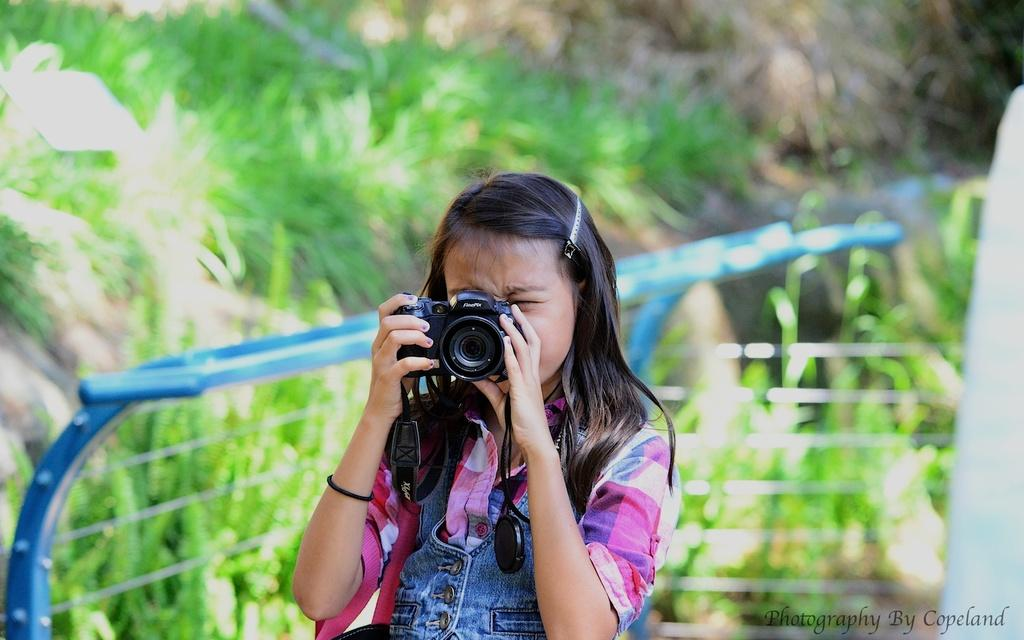Who is the main subject in the image? There is a girl in the center of the image. What is the girl holding in the image? The girl is holding a camera. What is the girl doing with the camera? The girl is clicking pictures. What can be seen in the background of the image? There are trees in the background of the image. What type of vegetation is present in the image? There are plants in the image. What type of hair is the chicken wearing in the image? There is no chicken present in the image, and therefore no hair to be worn. 